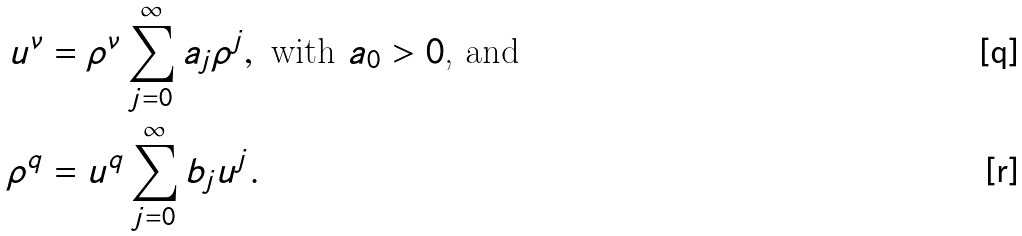<formula> <loc_0><loc_0><loc_500><loc_500>u ^ { \nu } & = \rho ^ { \nu } \sum _ { j = 0 } ^ { \infty } a _ { j } \rho ^ { j } , \text { with } a _ { 0 } > 0 \text {, and} \\ \rho ^ { q } & = u ^ { q } \sum _ { j = 0 } ^ { \infty } b _ { j } u ^ { j } .</formula> 